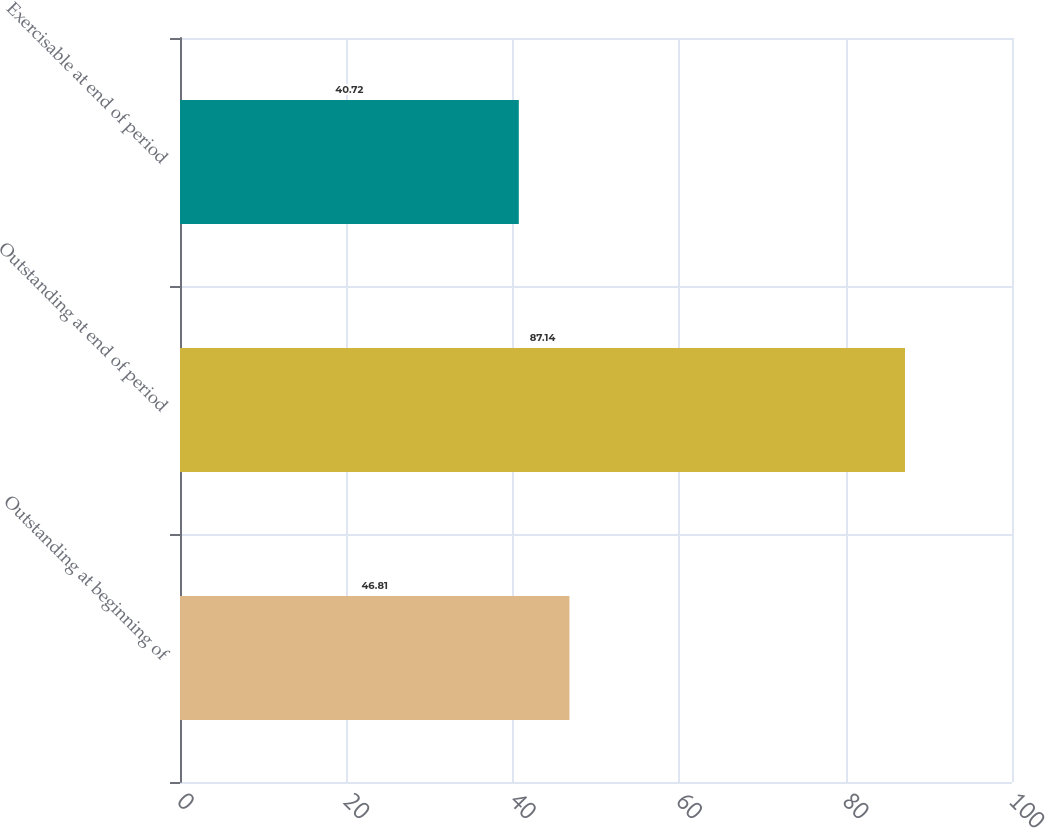<chart> <loc_0><loc_0><loc_500><loc_500><bar_chart><fcel>Outstanding at beginning of<fcel>Outstanding at end of period<fcel>Exercisable at end of period<nl><fcel>46.81<fcel>87.14<fcel>40.72<nl></chart> 